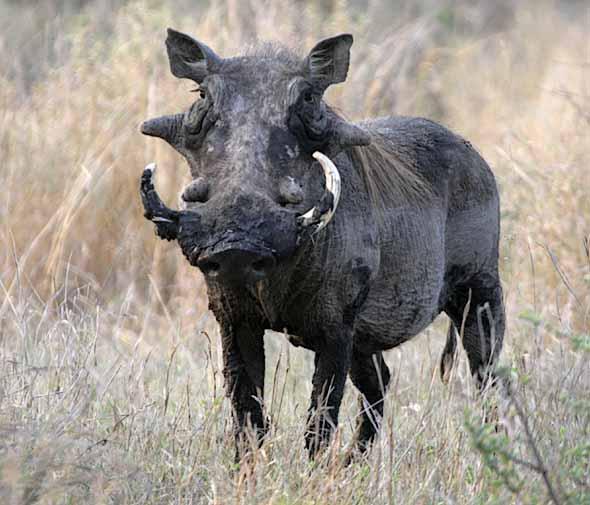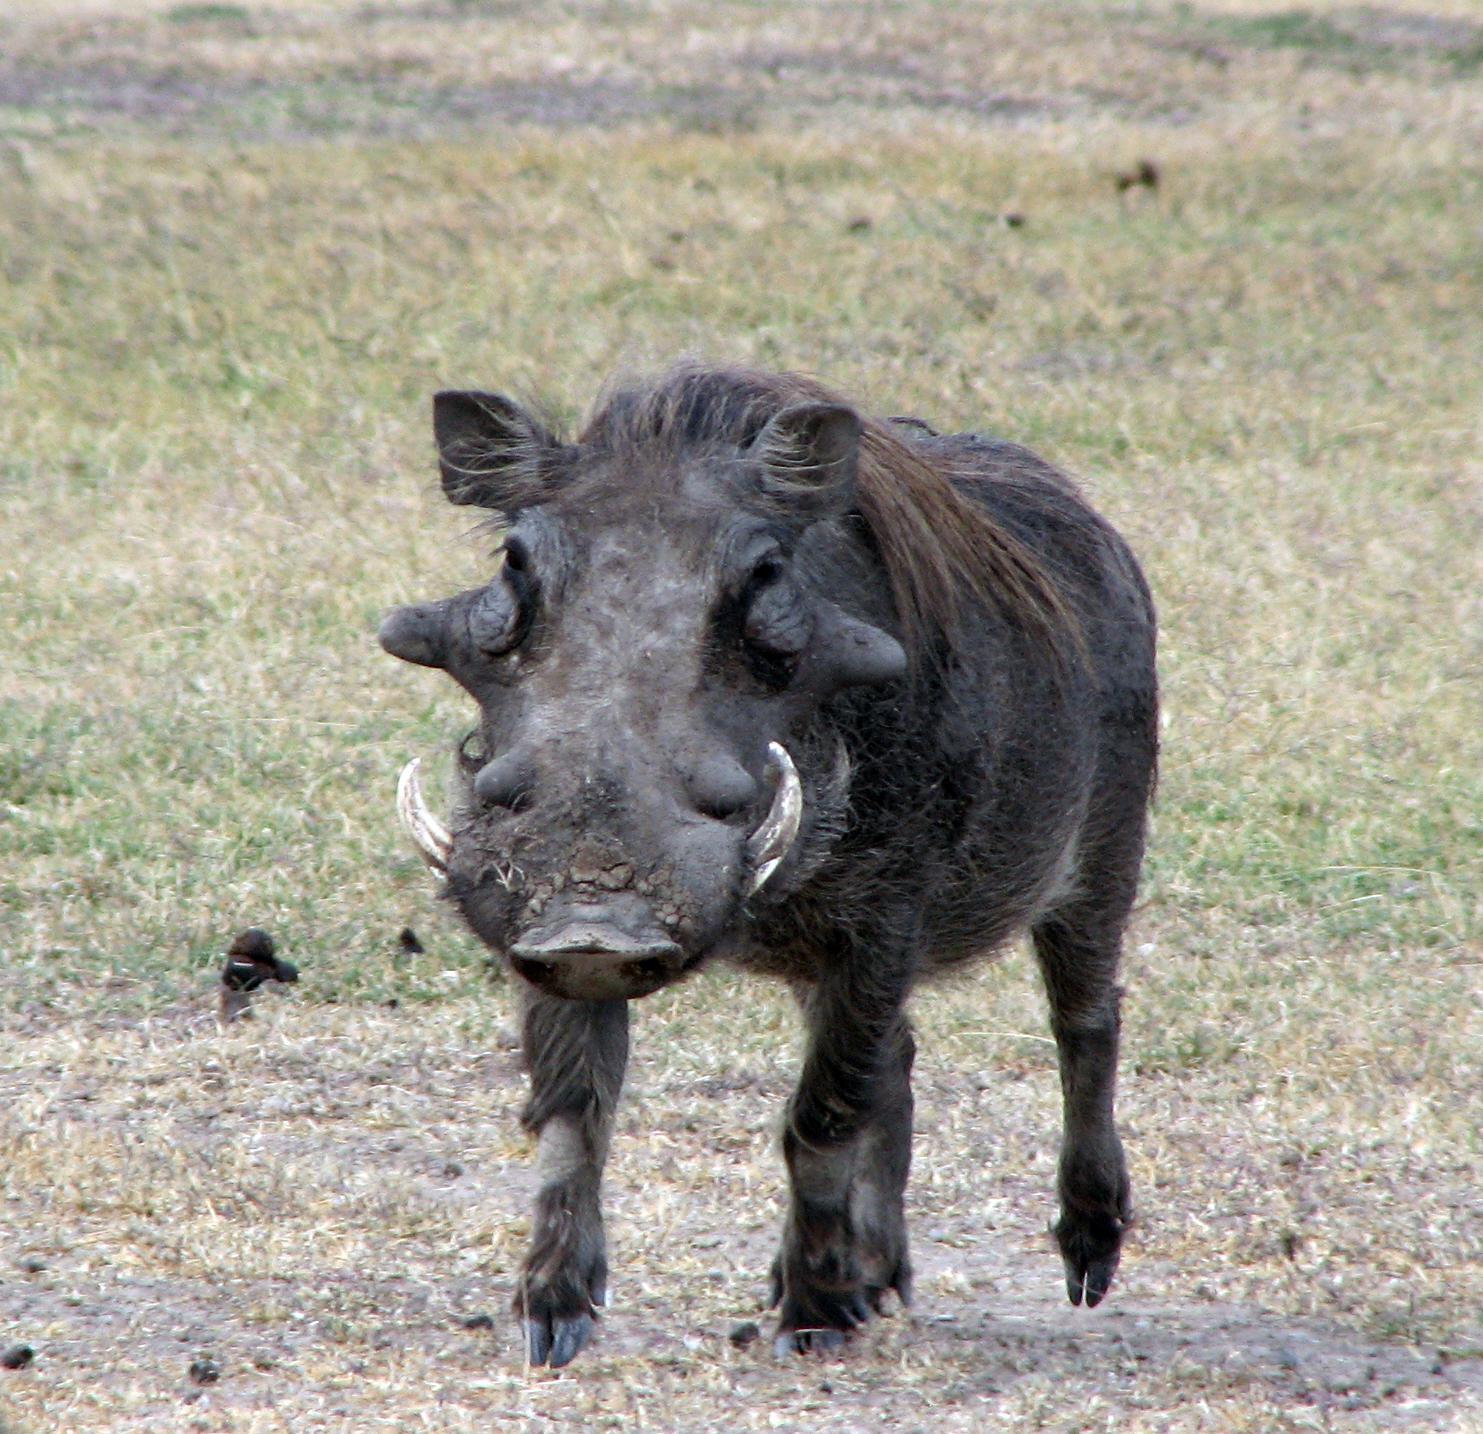The first image is the image on the left, the second image is the image on the right. Given the left and right images, does the statement "There are two hogs facing left." hold true? Answer yes or no. Yes. 